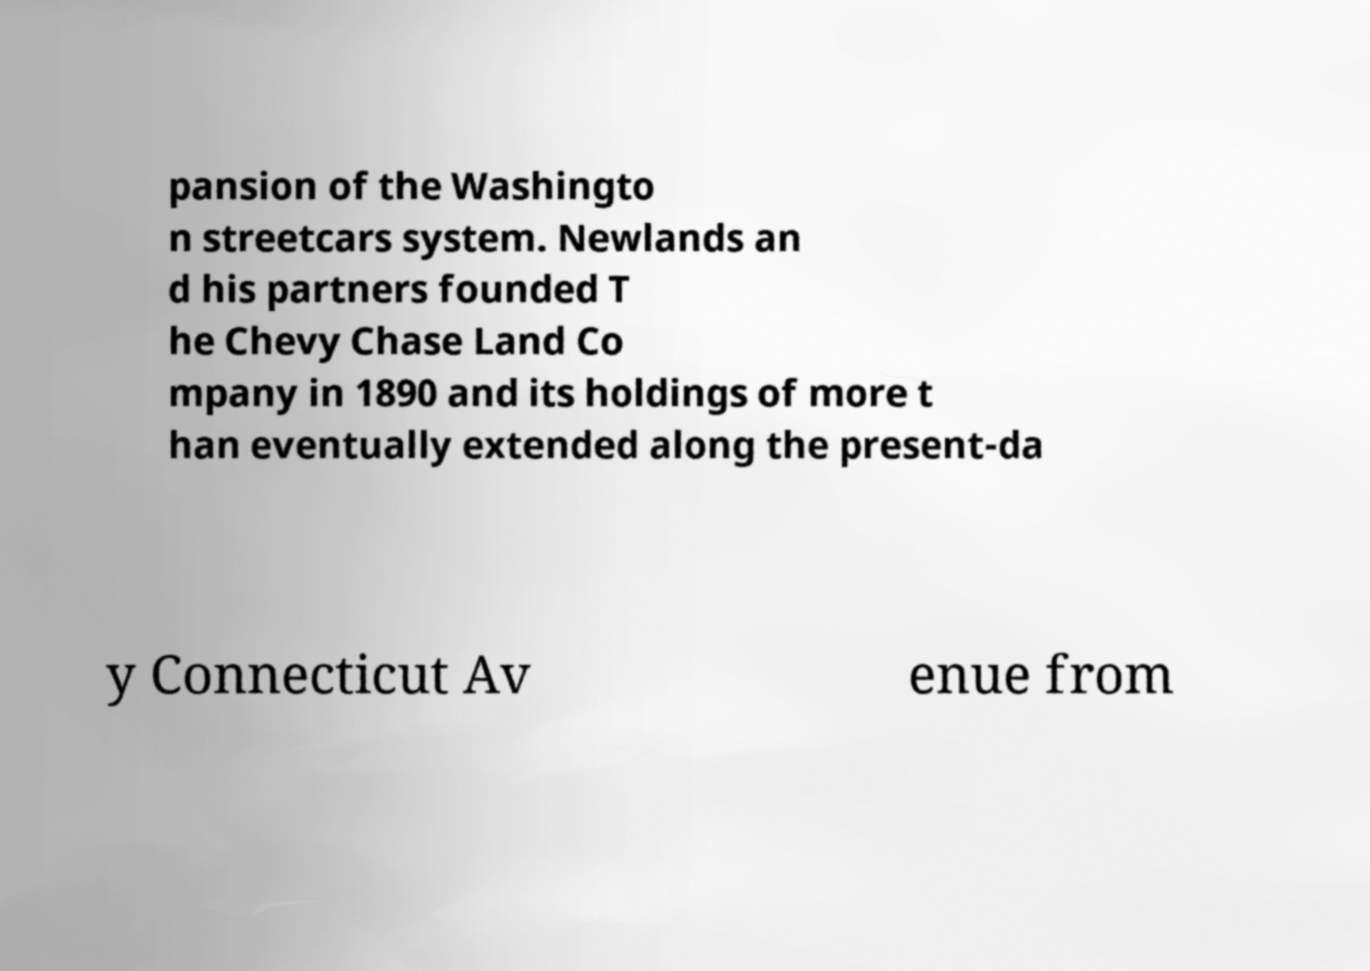Could you assist in decoding the text presented in this image and type it out clearly? pansion of the Washingto n streetcars system. Newlands an d his partners founded T he Chevy Chase Land Co mpany in 1890 and its holdings of more t han eventually extended along the present-da y Connecticut Av enue from 